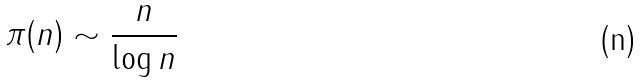<formula> <loc_0><loc_0><loc_500><loc_500>\pi ( n ) \sim \frac { n } { \log n }</formula> 